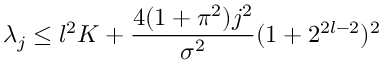<formula> <loc_0><loc_0><loc_500><loc_500>\lambda _ { j } \leq l ^ { 2 } K + \frac { 4 ( 1 + \pi ^ { 2 } ) j ^ { 2 } } { \sigma ^ { 2 } } ( 1 + 2 ^ { 2 l - 2 } ) ^ { 2 }</formula> 